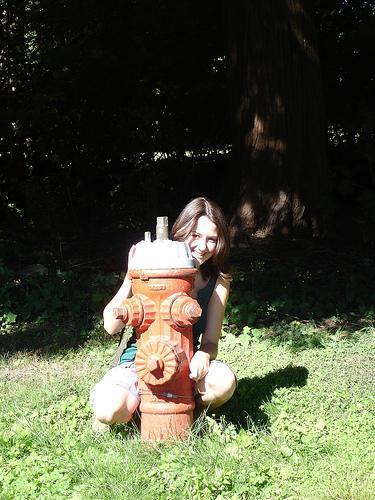How many spouts does the fire hydrant have?
Give a very brief answer. 3. 